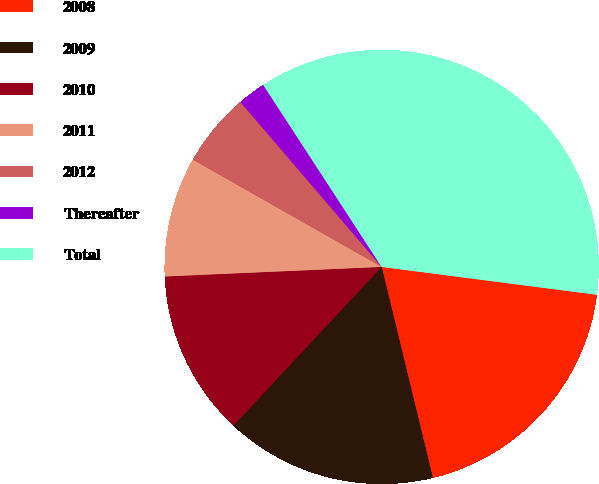<chart> <loc_0><loc_0><loc_500><loc_500><pie_chart><fcel>2008<fcel>2009<fcel>2010<fcel>2011<fcel>2012<fcel>Thereafter<fcel>Total<nl><fcel>19.16%<fcel>15.75%<fcel>12.34%<fcel>8.92%<fcel>5.51%<fcel>2.09%<fcel>36.23%<nl></chart> 